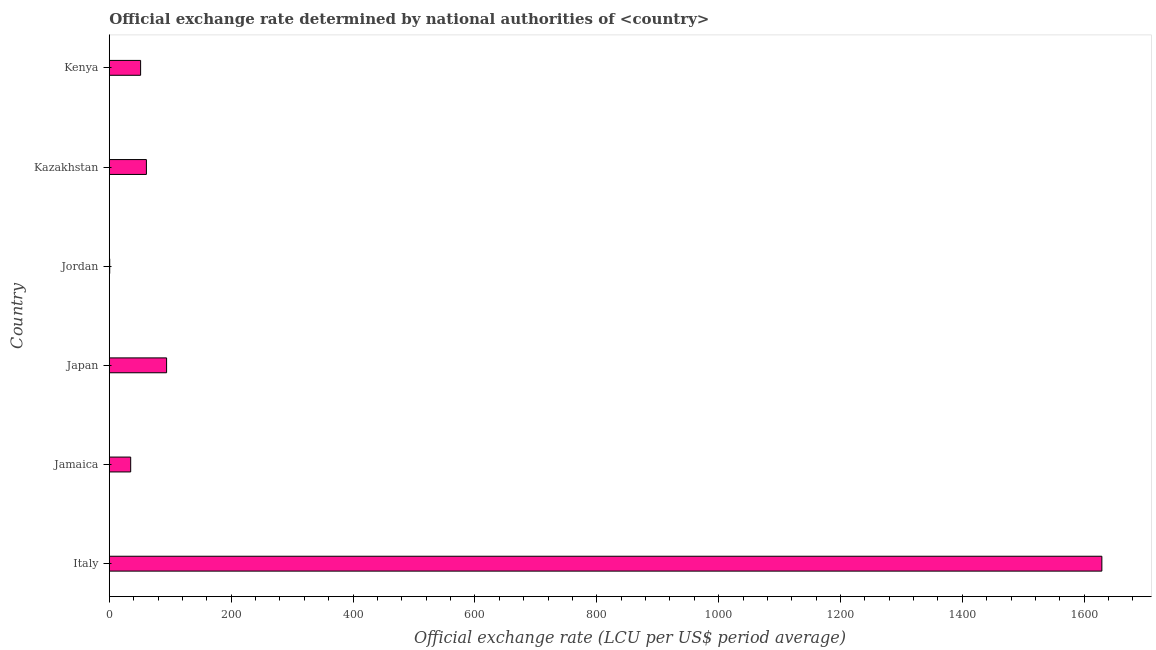Does the graph contain any zero values?
Keep it short and to the point. No. Does the graph contain grids?
Give a very brief answer. No. What is the title of the graph?
Make the answer very short. Official exchange rate determined by national authorities of <country>. What is the label or title of the X-axis?
Your answer should be very brief. Official exchange rate (LCU per US$ period average). What is the label or title of the Y-axis?
Your answer should be very brief. Country. What is the official exchange rate in Italy?
Your answer should be compact. 1628.93. Across all countries, what is the maximum official exchange rate?
Your answer should be compact. 1628.93. Across all countries, what is the minimum official exchange rate?
Provide a succinct answer. 0.7. In which country was the official exchange rate minimum?
Make the answer very short. Jordan. What is the sum of the official exchange rate?
Your response must be concise. 1871.22. What is the difference between the official exchange rate in Japan and Kazakhstan?
Keep it short and to the point. 33.11. What is the average official exchange rate per country?
Offer a very short reply. 311.87. What is the median official exchange rate?
Provide a succinct answer. 56.19. In how many countries, is the official exchange rate greater than 1320 ?
Your response must be concise. 1. What is the ratio of the official exchange rate in Italy to that in Jamaica?
Provide a succinct answer. 46.35. Is the official exchange rate in Italy less than that in Jamaica?
Your answer should be compact. No. What is the difference between the highest and the second highest official exchange rate?
Make the answer very short. 1534.87. What is the difference between the highest and the lowest official exchange rate?
Provide a succinct answer. 1628.23. In how many countries, is the official exchange rate greater than the average official exchange rate taken over all countries?
Provide a short and direct response. 1. How many bars are there?
Ensure brevity in your answer.  6. Are all the bars in the graph horizontal?
Offer a terse response. Yes. How many countries are there in the graph?
Keep it short and to the point. 6. Are the values on the major ticks of X-axis written in scientific E-notation?
Offer a very short reply. No. What is the Official exchange rate (LCU per US$ period average) of Italy?
Make the answer very short. 1628.93. What is the Official exchange rate (LCU per US$ period average) in Jamaica?
Provide a short and direct response. 35.14. What is the Official exchange rate (LCU per US$ period average) in Japan?
Offer a terse response. 94.06. What is the Official exchange rate (LCU per US$ period average) of Jordan?
Offer a terse response. 0.7. What is the Official exchange rate (LCU per US$ period average) of Kazakhstan?
Provide a short and direct response. 60.95. What is the Official exchange rate (LCU per US$ period average) in Kenya?
Your answer should be compact. 51.43. What is the difference between the Official exchange rate (LCU per US$ period average) in Italy and Jamaica?
Give a very brief answer. 1593.79. What is the difference between the Official exchange rate (LCU per US$ period average) in Italy and Japan?
Your answer should be very brief. 1534.87. What is the difference between the Official exchange rate (LCU per US$ period average) in Italy and Jordan?
Give a very brief answer. 1628.23. What is the difference between the Official exchange rate (LCU per US$ period average) in Italy and Kazakhstan?
Your answer should be very brief. 1567.98. What is the difference between the Official exchange rate (LCU per US$ period average) in Italy and Kenya?
Ensure brevity in your answer.  1577.5. What is the difference between the Official exchange rate (LCU per US$ period average) in Jamaica and Japan?
Provide a succinct answer. -58.92. What is the difference between the Official exchange rate (LCU per US$ period average) in Jamaica and Jordan?
Offer a terse response. 34.44. What is the difference between the Official exchange rate (LCU per US$ period average) in Jamaica and Kazakhstan?
Provide a short and direct response. -25.81. What is the difference between the Official exchange rate (LCU per US$ period average) in Jamaica and Kenya?
Offer a terse response. -16.29. What is the difference between the Official exchange rate (LCU per US$ period average) in Japan and Jordan?
Provide a succinct answer. 93.36. What is the difference between the Official exchange rate (LCU per US$ period average) in Japan and Kazakhstan?
Your answer should be very brief. 33.11. What is the difference between the Official exchange rate (LCU per US$ period average) in Japan and Kenya?
Your answer should be very brief. 42.63. What is the difference between the Official exchange rate (LCU per US$ period average) in Jordan and Kazakhstan?
Offer a terse response. -60.25. What is the difference between the Official exchange rate (LCU per US$ period average) in Jordan and Kenya?
Your answer should be very brief. -50.73. What is the difference between the Official exchange rate (LCU per US$ period average) in Kazakhstan and Kenya?
Keep it short and to the point. 9.52. What is the ratio of the Official exchange rate (LCU per US$ period average) in Italy to that in Jamaica?
Ensure brevity in your answer.  46.35. What is the ratio of the Official exchange rate (LCU per US$ period average) in Italy to that in Japan?
Keep it short and to the point. 17.32. What is the ratio of the Official exchange rate (LCU per US$ period average) in Italy to that in Jordan?
Make the answer very short. 2325.79. What is the ratio of the Official exchange rate (LCU per US$ period average) in Italy to that in Kazakhstan?
Provide a short and direct response. 26.73. What is the ratio of the Official exchange rate (LCU per US$ period average) in Italy to that in Kenya?
Provide a short and direct response. 31.67. What is the ratio of the Official exchange rate (LCU per US$ period average) in Jamaica to that in Japan?
Offer a terse response. 0.37. What is the ratio of the Official exchange rate (LCU per US$ period average) in Jamaica to that in Jordan?
Your answer should be very brief. 50.18. What is the ratio of the Official exchange rate (LCU per US$ period average) in Jamaica to that in Kazakhstan?
Make the answer very short. 0.58. What is the ratio of the Official exchange rate (LCU per US$ period average) in Jamaica to that in Kenya?
Ensure brevity in your answer.  0.68. What is the ratio of the Official exchange rate (LCU per US$ period average) in Japan to that in Jordan?
Give a very brief answer. 134.3. What is the ratio of the Official exchange rate (LCU per US$ period average) in Japan to that in Kazakhstan?
Provide a succinct answer. 1.54. What is the ratio of the Official exchange rate (LCU per US$ period average) in Japan to that in Kenya?
Give a very brief answer. 1.83. What is the ratio of the Official exchange rate (LCU per US$ period average) in Jordan to that in Kazakhstan?
Provide a succinct answer. 0.01. What is the ratio of the Official exchange rate (LCU per US$ period average) in Jordan to that in Kenya?
Provide a succinct answer. 0.01. What is the ratio of the Official exchange rate (LCU per US$ period average) in Kazakhstan to that in Kenya?
Offer a terse response. 1.19. 